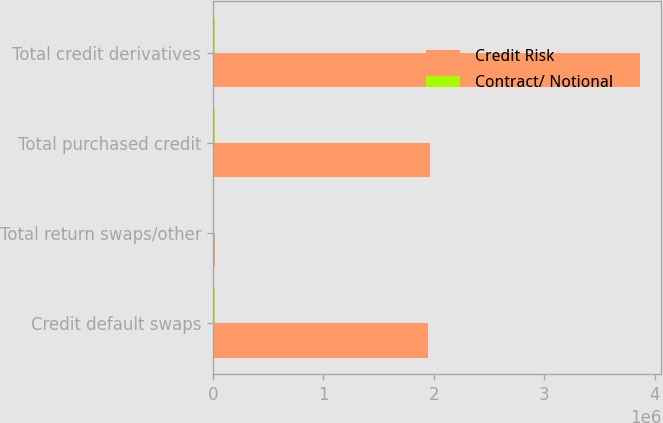<chart> <loc_0><loc_0><loc_500><loc_500><stacked_bar_chart><ecel><fcel>Credit default swaps<fcel>Total return swaps/other<fcel>Total purchased credit<fcel>Total credit derivatives<nl><fcel>Credit Risk<fcel>1.94476e+06<fcel>17519<fcel>1.96228e+06<fcel>3.86606e+06<nl><fcel>Contract/ Notional<fcel>14163<fcel>776<fcel>14939<fcel>14939<nl></chart> 